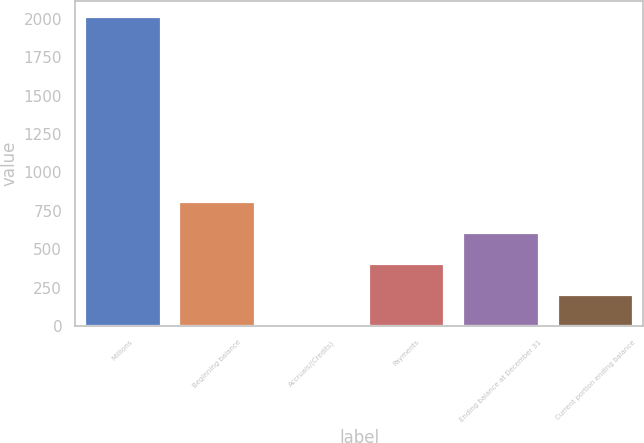Convert chart to OTSL. <chart><loc_0><loc_0><loc_500><loc_500><bar_chart><fcel>Millions<fcel>Beginning balance<fcel>Accruals/(Credits)<fcel>Payments<fcel>Ending balance at December 31<fcel>Current portion ending balance<nl><fcel>2013<fcel>806.4<fcel>2<fcel>404.2<fcel>605.3<fcel>203.1<nl></chart> 